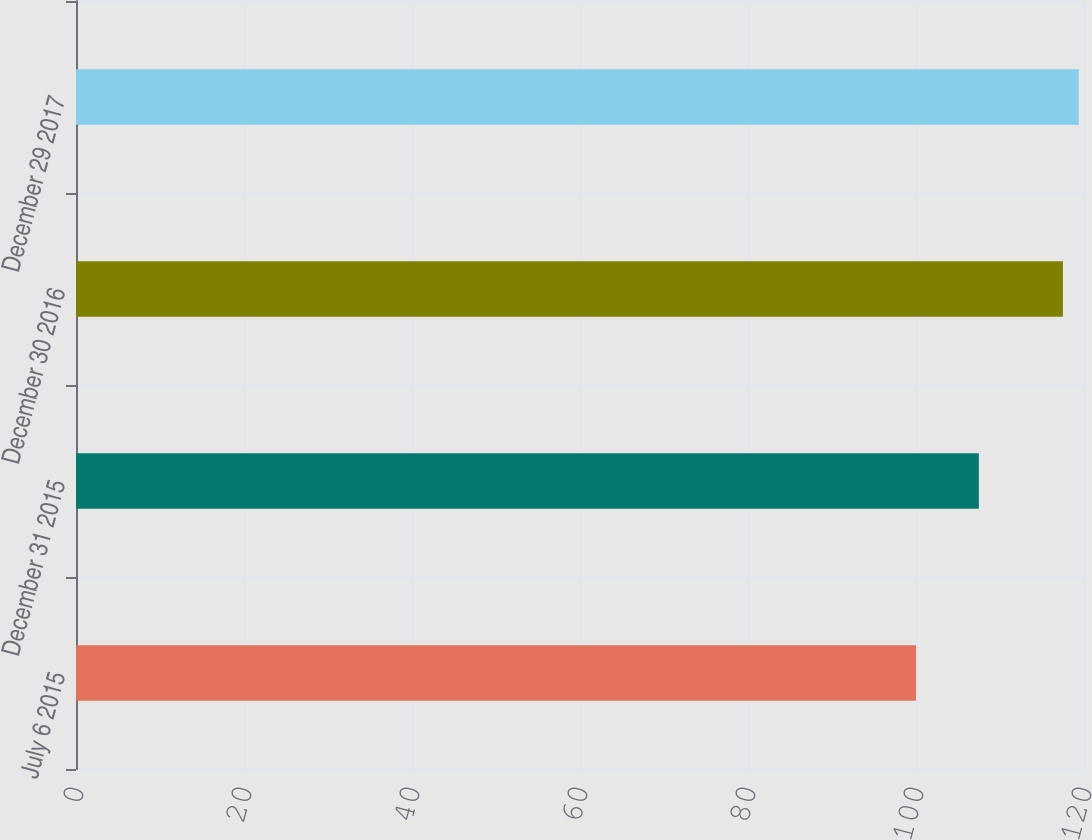Convert chart to OTSL. <chart><loc_0><loc_0><loc_500><loc_500><bar_chart><fcel>July 6 2015<fcel>December 31 2015<fcel>December 30 2016<fcel>December 29 2017<nl><fcel>100<fcel>107.48<fcel>117.49<fcel>119.38<nl></chart> 